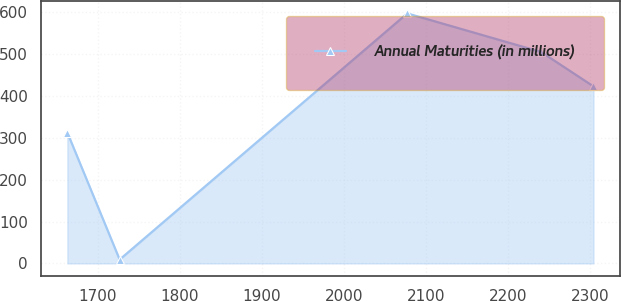Convert chart to OTSL. <chart><loc_0><loc_0><loc_500><loc_500><line_chart><ecel><fcel>Annual Maturities (in millions)<nl><fcel>1662.9<fcel>312.17<nl><fcel>1726.6<fcel>9.16<nl><fcel>2077.02<fcel>596.66<nl><fcel>2240.17<fcel>504.56<nl><fcel>2303.87<fcel>422.53<nl></chart> 